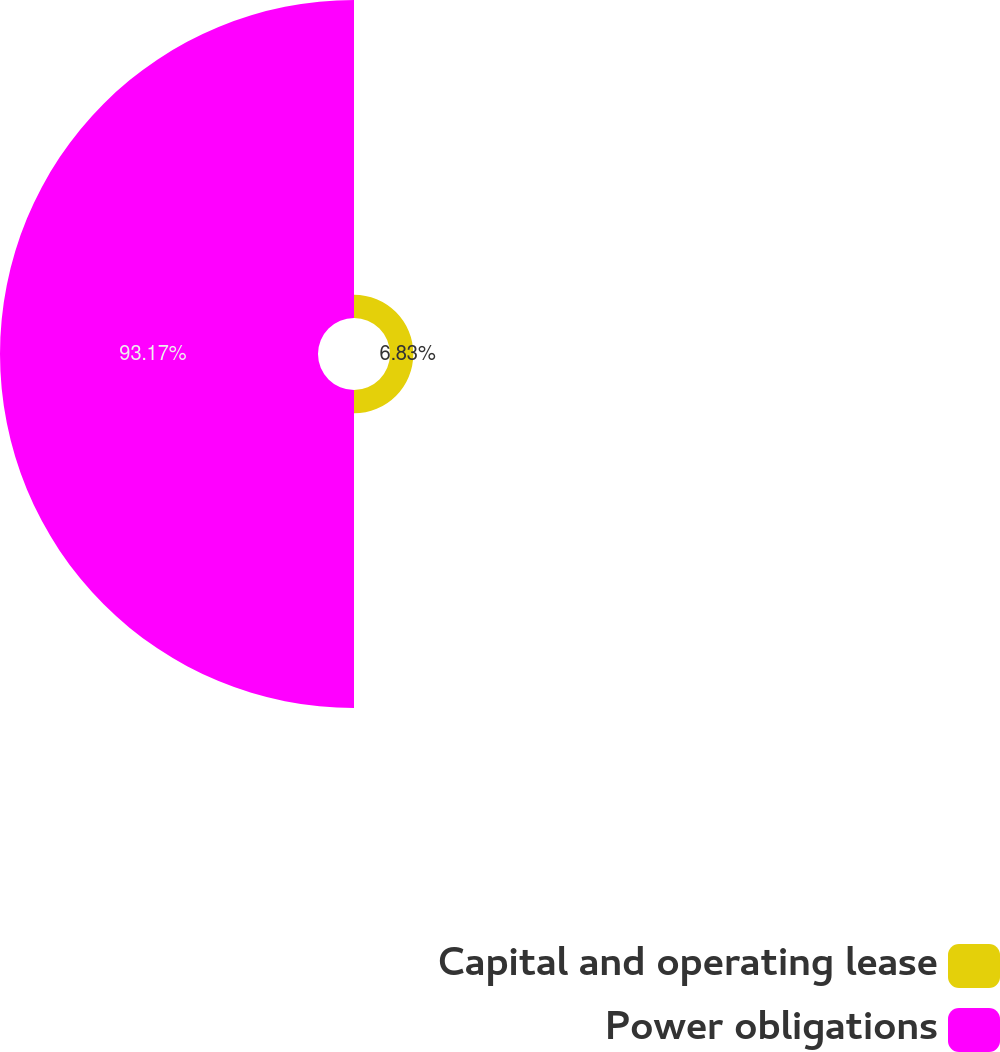<chart> <loc_0><loc_0><loc_500><loc_500><pie_chart><fcel>Capital and operating lease<fcel>Power obligations<nl><fcel>6.83%<fcel>93.17%<nl></chart> 